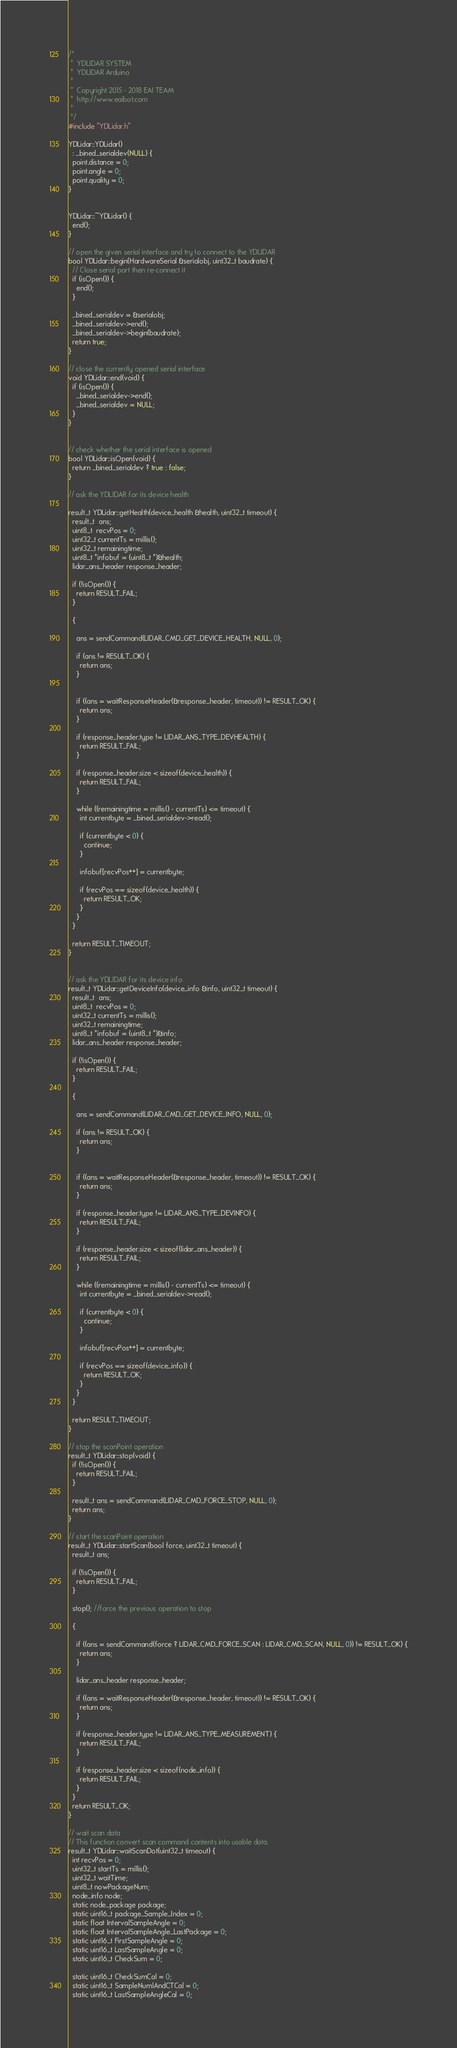<code> <loc_0><loc_0><loc_500><loc_500><_C++_>/*
 *  YDLIDAR SYSTEM
 *  YDLIDAR Arduino
 *
 *  Copyright 2015 - 2018 EAI TEAM
 *  http://www.eaibot.com
 *
 */
#include "YDLidar.h"

YDLidar::YDLidar()
  : _bined_serialdev(NULL) {
  point.distance = 0;
  point.angle = 0;
  point.quality = 0;
}


YDLidar::~YDLidar() {
  end();
}

// open the given serial interface and try to connect to the YDLIDAR
bool YDLidar::begin(HardwareSerial &serialobj, uint32_t baudrate) {
  // Close serial port then re-connect it
  if (isOpen()) {
    end();
  }

  _bined_serialdev = &serialobj;
  _bined_serialdev->end();
  _bined_serialdev->begin(baudrate);
  return true;
}

// close the currently opened serial interface
void YDLidar::end(void) {
  if (isOpen()) {
    _bined_serialdev->end();
    _bined_serialdev = NULL;
  }
}


// check whether the serial interface is opened
bool YDLidar::isOpen(void) {
  return _bined_serialdev ? true : false;
}

// ask the YDLIDAR for its device health

result_t YDLidar::getHealth(device_health &health, uint32_t timeout) {
  result_t  ans;
  uint8_t  recvPos = 0;
  uint32_t currentTs = millis();
  uint32_t remainingtime;
  uint8_t *infobuf = (uint8_t *)&health;
  lidar_ans_header response_header;

  if (!isOpen()) {
    return RESULT_FAIL;
  }

  {

    ans = sendCommand(LIDAR_CMD_GET_DEVICE_HEALTH, NULL, 0);

    if (ans != RESULT_OK) {
      return ans;
    }


    if ((ans = waitResponseHeader(&response_header, timeout)) != RESULT_OK) {
      return ans;
    }

    if (response_header.type != LIDAR_ANS_TYPE_DEVHEALTH) {
      return RESULT_FAIL;
    }

    if (response_header.size < sizeof(device_health)) {
      return RESULT_FAIL;
    }

    while ((remainingtime = millis() - currentTs) <= timeout) {
      int currentbyte = _bined_serialdev->read();

      if (currentbyte < 0) {
        continue;
      }

      infobuf[recvPos++] = currentbyte;

      if (recvPos == sizeof(device_health)) {
        return RESULT_OK;
      }
    }
  }

  return RESULT_TIMEOUT;
}


// ask the YDLIDAR for its device info
result_t YDLidar::getDeviceInfo(device_info &info, uint32_t timeout) {
  result_t  ans;
  uint8_t  recvPos = 0;
  uint32_t currentTs = millis();
  uint32_t remainingtime;
  uint8_t *infobuf = (uint8_t *)&info;
  lidar_ans_header response_header;

  if (!isOpen()) {
    return RESULT_FAIL;
  }

  {

    ans = sendCommand(LIDAR_CMD_GET_DEVICE_INFO, NULL, 0);

    if (ans != RESULT_OK) {
      return ans;
    }


    if ((ans = waitResponseHeader(&response_header, timeout)) != RESULT_OK) {
      return ans;
    }

    if (response_header.type != LIDAR_ANS_TYPE_DEVINFO) {
      return RESULT_FAIL;
    }

    if (response_header.size < sizeof(lidar_ans_header)) {
      return RESULT_FAIL;
    }

    while ((remainingtime = millis() - currentTs) <= timeout) {
      int currentbyte = _bined_serialdev->read();

      if (currentbyte < 0) {
        continue;
      }

      infobuf[recvPos++] = currentbyte;

      if (recvPos == sizeof(device_info)) {
        return RESULT_OK;
      }
    }
  }

  return RESULT_TIMEOUT;
}

// stop the scanPoint operation
result_t YDLidar::stop(void) {
  if (!isOpen()) {
    return RESULT_FAIL;
  }

  result_t ans = sendCommand(LIDAR_CMD_FORCE_STOP, NULL, 0);
  return ans;
}

// start the scanPoint operation
result_t YDLidar::startScan(bool force, uint32_t timeout) {
  result_t ans;

  if (!isOpen()) {
    return RESULT_FAIL;
  }

  stop(); //force the previous operation to stop

  {

    if ((ans = sendCommand(force ? LIDAR_CMD_FORCE_SCAN : LIDAR_CMD_SCAN, NULL, 0)) != RESULT_OK) {
      return ans;
    }

    lidar_ans_header response_header;

    if ((ans = waitResponseHeader(&response_header, timeout)) != RESULT_OK) {
      return ans;
    }

    if (response_header.type != LIDAR_ANS_TYPE_MEASUREMENT) {
      return RESULT_FAIL;
    }

    if (response_header.size < sizeof(node_info)) {
      return RESULT_FAIL;
    }
  }
  return RESULT_OK;
}

// wait scan data
// This function convert scan command contents into usable data.
result_t YDLidar::waitScanDot(uint32_t timeout) {
  int recvPos = 0;
  uint32_t startTs = millis();
  uint32_t waitTime;
  uint8_t nowPackageNum;
  node_info node;
  static node_package package;
  static uint16_t package_Sample_Index = 0;
  static float IntervalSampleAngle = 0;
  static float IntervalSampleAngle_LastPackage = 0;
  static uint16_t FirstSampleAngle = 0;
  static uint16_t LastSampleAngle = 0;
  static uint16_t CheckSum = 0;

  static uint16_t CheckSumCal = 0;
  static uint16_t SampleNumlAndCTCal = 0;
  static uint16_t LastSampleAngleCal = 0;</code> 